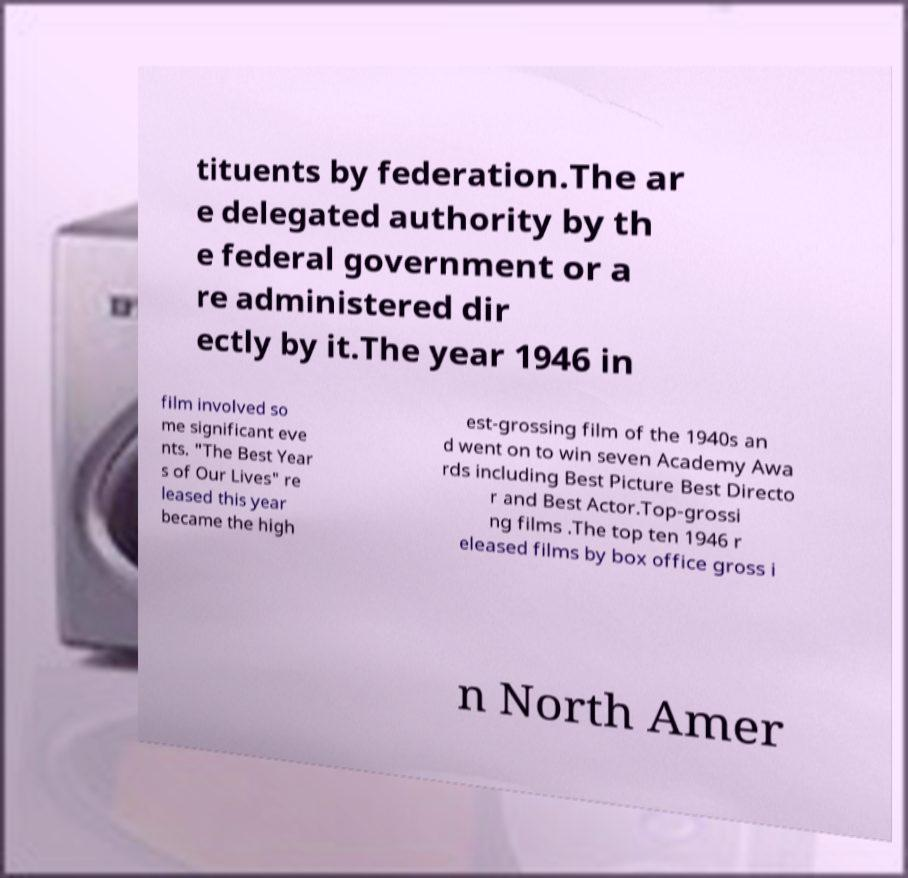There's text embedded in this image that I need extracted. Can you transcribe it verbatim? tituents by federation.The ar e delegated authority by th e federal government or a re administered dir ectly by it.The year 1946 in film involved so me significant eve nts. "The Best Year s of Our Lives" re leased this year became the high est-grossing film of the 1940s an d went on to win seven Academy Awa rds including Best Picture Best Directo r and Best Actor.Top-grossi ng films .The top ten 1946 r eleased films by box office gross i n North Amer 